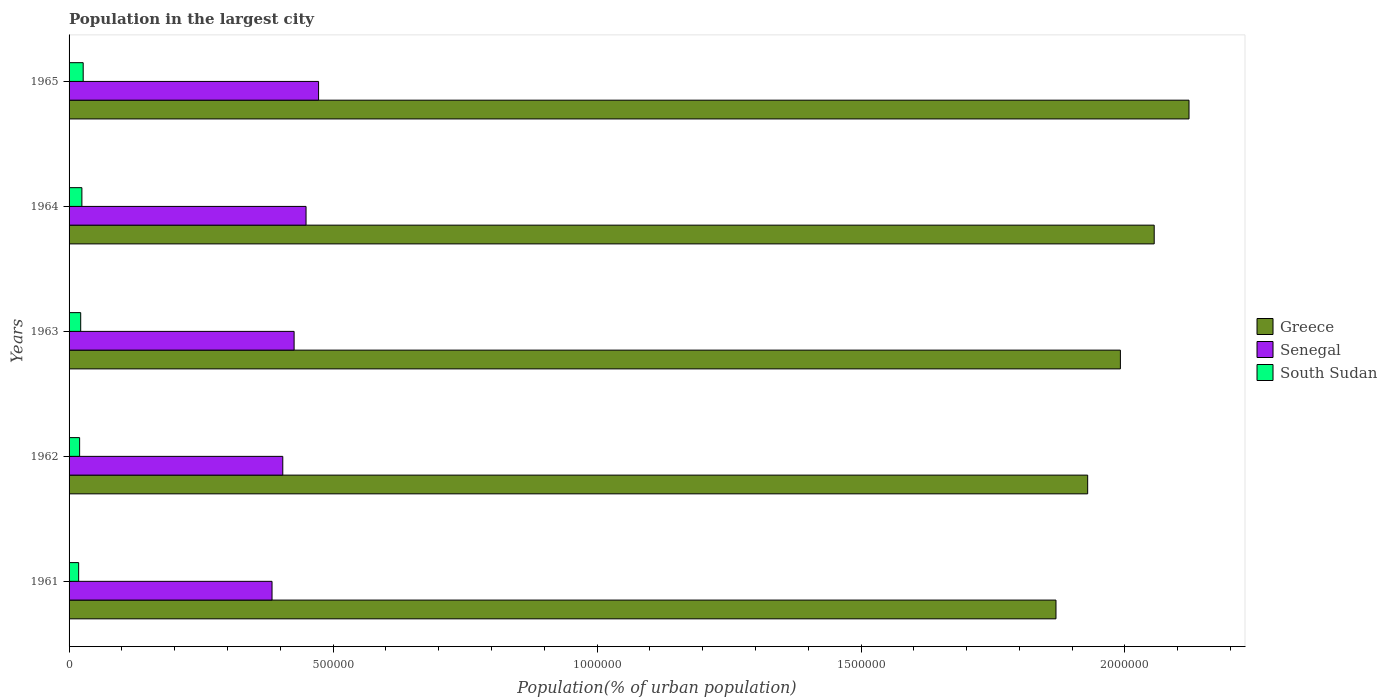Are the number of bars per tick equal to the number of legend labels?
Your answer should be very brief. Yes. Are the number of bars on each tick of the Y-axis equal?
Give a very brief answer. Yes. How many bars are there on the 2nd tick from the top?
Ensure brevity in your answer.  3. What is the label of the 2nd group of bars from the top?
Your answer should be very brief. 1964. What is the population in the largest city in Senegal in 1964?
Keep it short and to the point. 4.49e+05. Across all years, what is the maximum population in the largest city in Greece?
Make the answer very short. 2.12e+06. Across all years, what is the minimum population in the largest city in Senegal?
Your answer should be compact. 3.84e+05. In which year was the population in the largest city in South Sudan maximum?
Your answer should be compact. 1965. In which year was the population in the largest city in Senegal minimum?
Your answer should be very brief. 1961. What is the total population in the largest city in South Sudan in the graph?
Give a very brief answer. 1.11e+05. What is the difference between the population in the largest city in Senegal in 1961 and that in 1963?
Ensure brevity in your answer.  -4.18e+04. What is the difference between the population in the largest city in Greece in 1965 and the population in the largest city in South Sudan in 1961?
Ensure brevity in your answer.  2.10e+06. What is the average population in the largest city in Senegal per year?
Your answer should be compact. 4.27e+05. In the year 1963, what is the difference between the population in the largest city in Greece and population in the largest city in Senegal?
Ensure brevity in your answer.  1.57e+06. In how many years, is the population in the largest city in Greece greater than 1600000 %?
Give a very brief answer. 5. What is the ratio of the population in the largest city in Senegal in 1961 to that in 1965?
Your answer should be compact. 0.81. Is the population in the largest city in South Sudan in 1961 less than that in 1963?
Offer a very short reply. Yes. Is the difference between the population in the largest city in Greece in 1962 and 1965 greater than the difference between the population in the largest city in Senegal in 1962 and 1965?
Ensure brevity in your answer.  No. What is the difference between the highest and the second highest population in the largest city in Senegal?
Keep it short and to the point. 2.37e+04. What is the difference between the highest and the lowest population in the largest city in South Sudan?
Your answer should be compact. 8598. What does the 3rd bar from the top in 1962 represents?
Make the answer very short. Greece. Is it the case that in every year, the sum of the population in the largest city in South Sudan and population in the largest city in Senegal is greater than the population in the largest city in Greece?
Give a very brief answer. No. How many years are there in the graph?
Your answer should be compact. 5. Are the values on the major ticks of X-axis written in scientific E-notation?
Give a very brief answer. No. Does the graph contain any zero values?
Provide a short and direct response. No. Where does the legend appear in the graph?
Make the answer very short. Center right. What is the title of the graph?
Provide a succinct answer. Population in the largest city. Does "Faeroe Islands" appear as one of the legend labels in the graph?
Provide a succinct answer. No. What is the label or title of the X-axis?
Keep it short and to the point. Population(% of urban population). What is the label or title of the Y-axis?
Keep it short and to the point. Years. What is the Population(% of urban population) in Greece in 1961?
Make the answer very short. 1.87e+06. What is the Population(% of urban population) of Senegal in 1961?
Keep it short and to the point. 3.84e+05. What is the Population(% of urban population) in South Sudan in 1961?
Make the answer very short. 1.82e+04. What is the Population(% of urban population) in Greece in 1962?
Give a very brief answer. 1.93e+06. What is the Population(% of urban population) of Senegal in 1962?
Keep it short and to the point. 4.05e+05. What is the Population(% of urban population) in South Sudan in 1962?
Offer a terse response. 2.00e+04. What is the Population(% of urban population) in Greece in 1963?
Your answer should be very brief. 1.99e+06. What is the Population(% of urban population) of Senegal in 1963?
Give a very brief answer. 4.26e+05. What is the Population(% of urban population) of South Sudan in 1963?
Your response must be concise. 2.20e+04. What is the Population(% of urban population) in Greece in 1964?
Give a very brief answer. 2.06e+06. What is the Population(% of urban population) of Senegal in 1964?
Your answer should be compact. 4.49e+05. What is the Population(% of urban population) of South Sudan in 1964?
Give a very brief answer. 2.43e+04. What is the Population(% of urban population) of Greece in 1965?
Keep it short and to the point. 2.12e+06. What is the Population(% of urban population) of Senegal in 1965?
Your answer should be very brief. 4.73e+05. What is the Population(% of urban population) in South Sudan in 1965?
Provide a succinct answer. 2.68e+04. Across all years, what is the maximum Population(% of urban population) of Greece?
Provide a short and direct response. 2.12e+06. Across all years, what is the maximum Population(% of urban population) in Senegal?
Provide a short and direct response. 4.73e+05. Across all years, what is the maximum Population(% of urban population) in South Sudan?
Give a very brief answer. 2.68e+04. Across all years, what is the minimum Population(% of urban population) in Greece?
Your answer should be very brief. 1.87e+06. Across all years, what is the minimum Population(% of urban population) of Senegal?
Your answer should be very brief. 3.84e+05. Across all years, what is the minimum Population(% of urban population) in South Sudan?
Offer a terse response. 1.82e+04. What is the total Population(% of urban population) in Greece in the graph?
Offer a terse response. 9.97e+06. What is the total Population(% of urban population) of Senegal in the graph?
Provide a short and direct response. 2.14e+06. What is the total Population(% of urban population) in South Sudan in the graph?
Keep it short and to the point. 1.11e+05. What is the difference between the Population(% of urban population) of Greece in 1961 and that in 1962?
Your answer should be very brief. -6.00e+04. What is the difference between the Population(% of urban population) of Senegal in 1961 and that in 1962?
Offer a terse response. -2.04e+04. What is the difference between the Population(% of urban population) in South Sudan in 1961 and that in 1962?
Your answer should be very brief. -1848. What is the difference between the Population(% of urban population) of Greece in 1961 and that in 1963?
Offer a terse response. -1.22e+05. What is the difference between the Population(% of urban population) in Senegal in 1961 and that in 1963?
Give a very brief answer. -4.18e+04. What is the difference between the Population(% of urban population) in South Sudan in 1961 and that in 1963?
Give a very brief answer. -3884. What is the difference between the Population(% of urban population) of Greece in 1961 and that in 1964?
Ensure brevity in your answer.  -1.86e+05. What is the difference between the Population(% of urban population) in Senegal in 1961 and that in 1964?
Ensure brevity in your answer.  -6.44e+04. What is the difference between the Population(% of urban population) in South Sudan in 1961 and that in 1964?
Provide a succinct answer. -6130. What is the difference between the Population(% of urban population) in Greece in 1961 and that in 1965?
Your response must be concise. -2.52e+05. What is the difference between the Population(% of urban population) of Senegal in 1961 and that in 1965?
Your answer should be compact. -8.82e+04. What is the difference between the Population(% of urban population) in South Sudan in 1961 and that in 1965?
Make the answer very short. -8598. What is the difference between the Population(% of urban population) in Greece in 1962 and that in 1963?
Keep it short and to the point. -6.20e+04. What is the difference between the Population(% of urban population) of Senegal in 1962 and that in 1963?
Keep it short and to the point. -2.14e+04. What is the difference between the Population(% of urban population) in South Sudan in 1962 and that in 1963?
Keep it short and to the point. -2036. What is the difference between the Population(% of urban population) in Greece in 1962 and that in 1964?
Provide a succinct answer. -1.26e+05. What is the difference between the Population(% of urban population) of Senegal in 1962 and that in 1964?
Provide a short and direct response. -4.41e+04. What is the difference between the Population(% of urban population) in South Sudan in 1962 and that in 1964?
Provide a succinct answer. -4282. What is the difference between the Population(% of urban population) in Greece in 1962 and that in 1965?
Give a very brief answer. -1.92e+05. What is the difference between the Population(% of urban population) of Senegal in 1962 and that in 1965?
Your answer should be compact. -6.78e+04. What is the difference between the Population(% of urban population) in South Sudan in 1962 and that in 1965?
Provide a succinct answer. -6750. What is the difference between the Population(% of urban population) in Greece in 1963 and that in 1964?
Make the answer very short. -6.40e+04. What is the difference between the Population(% of urban population) of Senegal in 1963 and that in 1964?
Provide a short and direct response. -2.26e+04. What is the difference between the Population(% of urban population) of South Sudan in 1963 and that in 1964?
Offer a very short reply. -2246. What is the difference between the Population(% of urban population) of Greece in 1963 and that in 1965?
Offer a very short reply. -1.30e+05. What is the difference between the Population(% of urban population) in Senegal in 1963 and that in 1965?
Ensure brevity in your answer.  -4.64e+04. What is the difference between the Population(% of urban population) in South Sudan in 1963 and that in 1965?
Make the answer very short. -4714. What is the difference between the Population(% of urban population) of Greece in 1964 and that in 1965?
Give a very brief answer. -6.59e+04. What is the difference between the Population(% of urban population) in Senegal in 1964 and that in 1965?
Your answer should be very brief. -2.37e+04. What is the difference between the Population(% of urban population) of South Sudan in 1964 and that in 1965?
Offer a very short reply. -2468. What is the difference between the Population(% of urban population) in Greece in 1961 and the Population(% of urban population) in Senegal in 1962?
Your response must be concise. 1.46e+06. What is the difference between the Population(% of urban population) in Greece in 1961 and the Population(% of urban population) in South Sudan in 1962?
Ensure brevity in your answer.  1.85e+06. What is the difference between the Population(% of urban population) of Senegal in 1961 and the Population(% of urban population) of South Sudan in 1962?
Offer a very short reply. 3.64e+05. What is the difference between the Population(% of urban population) in Greece in 1961 and the Population(% of urban population) in Senegal in 1963?
Give a very brief answer. 1.44e+06. What is the difference between the Population(% of urban population) of Greece in 1961 and the Population(% of urban population) of South Sudan in 1963?
Offer a very short reply. 1.85e+06. What is the difference between the Population(% of urban population) in Senegal in 1961 and the Population(% of urban population) in South Sudan in 1963?
Your answer should be very brief. 3.62e+05. What is the difference between the Population(% of urban population) in Greece in 1961 and the Population(% of urban population) in Senegal in 1964?
Keep it short and to the point. 1.42e+06. What is the difference between the Population(% of urban population) in Greece in 1961 and the Population(% of urban population) in South Sudan in 1964?
Ensure brevity in your answer.  1.85e+06. What is the difference between the Population(% of urban population) of Senegal in 1961 and the Population(% of urban population) of South Sudan in 1964?
Make the answer very short. 3.60e+05. What is the difference between the Population(% of urban population) of Greece in 1961 and the Population(% of urban population) of Senegal in 1965?
Ensure brevity in your answer.  1.40e+06. What is the difference between the Population(% of urban population) in Greece in 1961 and the Population(% of urban population) in South Sudan in 1965?
Offer a very short reply. 1.84e+06. What is the difference between the Population(% of urban population) in Senegal in 1961 and the Population(% of urban population) in South Sudan in 1965?
Your answer should be very brief. 3.58e+05. What is the difference between the Population(% of urban population) in Greece in 1962 and the Population(% of urban population) in Senegal in 1963?
Keep it short and to the point. 1.50e+06. What is the difference between the Population(% of urban population) of Greece in 1962 and the Population(% of urban population) of South Sudan in 1963?
Your response must be concise. 1.91e+06. What is the difference between the Population(% of urban population) of Senegal in 1962 and the Population(% of urban population) of South Sudan in 1963?
Provide a short and direct response. 3.83e+05. What is the difference between the Population(% of urban population) in Greece in 1962 and the Population(% of urban population) in Senegal in 1964?
Ensure brevity in your answer.  1.48e+06. What is the difference between the Population(% of urban population) in Greece in 1962 and the Population(% of urban population) in South Sudan in 1964?
Provide a short and direct response. 1.91e+06. What is the difference between the Population(% of urban population) of Senegal in 1962 and the Population(% of urban population) of South Sudan in 1964?
Give a very brief answer. 3.81e+05. What is the difference between the Population(% of urban population) in Greece in 1962 and the Population(% of urban population) in Senegal in 1965?
Your answer should be compact. 1.46e+06. What is the difference between the Population(% of urban population) in Greece in 1962 and the Population(% of urban population) in South Sudan in 1965?
Ensure brevity in your answer.  1.90e+06. What is the difference between the Population(% of urban population) of Senegal in 1962 and the Population(% of urban population) of South Sudan in 1965?
Offer a very short reply. 3.78e+05. What is the difference between the Population(% of urban population) of Greece in 1963 and the Population(% of urban population) of Senegal in 1964?
Offer a terse response. 1.54e+06. What is the difference between the Population(% of urban population) in Greece in 1963 and the Population(% of urban population) in South Sudan in 1964?
Ensure brevity in your answer.  1.97e+06. What is the difference between the Population(% of urban population) in Senegal in 1963 and the Population(% of urban population) in South Sudan in 1964?
Your response must be concise. 4.02e+05. What is the difference between the Population(% of urban population) in Greece in 1963 and the Population(% of urban population) in Senegal in 1965?
Your answer should be compact. 1.52e+06. What is the difference between the Population(% of urban population) in Greece in 1963 and the Population(% of urban population) in South Sudan in 1965?
Offer a very short reply. 1.96e+06. What is the difference between the Population(% of urban population) in Senegal in 1963 and the Population(% of urban population) in South Sudan in 1965?
Provide a succinct answer. 3.99e+05. What is the difference between the Population(% of urban population) in Greece in 1964 and the Population(% of urban population) in Senegal in 1965?
Offer a terse response. 1.58e+06. What is the difference between the Population(% of urban population) of Greece in 1964 and the Population(% of urban population) of South Sudan in 1965?
Provide a short and direct response. 2.03e+06. What is the difference between the Population(% of urban population) of Senegal in 1964 and the Population(% of urban population) of South Sudan in 1965?
Make the answer very short. 4.22e+05. What is the average Population(% of urban population) in Greece per year?
Your answer should be very brief. 1.99e+06. What is the average Population(% of urban population) in Senegal per year?
Your answer should be compact. 4.27e+05. What is the average Population(% of urban population) of South Sudan per year?
Provide a short and direct response. 2.22e+04. In the year 1961, what is the difference between the Population(% of urban population) of Greece and Population(% of urban population) of Senegal?
Your response must be concise. 1.48e+06. In the year 1961, what is the difference between the Population(% of urban population) in Greece and Population(% of urban population) in South Sudan?
Give a very brief answer. 1.85e+06. In the year 1961, what is the difference between the Population(% of urban population) of Senegal and Population(% of urban population) of South Sudan?
Your answer should be compact. 3.66e+05. In the year 1962, what is the difference between the Population(% of urban population) in Greece and Population(% of urban population) in Senegal?
Make the answer very short. 1.52e+06. In the year 1962, what is the difference between the Population(% of urban population) of Greece and Population(% of urban population) of South Sudan?
Your answer should be compact. 1.91e+06. In the year 1962, what is the difference between the Population(% of urban population) of Senegal and Population(% of urban population) of South Sudan?
Keep it short and to the point. 3.85e+05. In the year 1963, what is the difference between the Population(% of urban population) in Greece and Population(% of urban population) in Senegal?
Keep it short and to the point. 1.57e+06. In the year 1963, what is the difference between the Population(% of urban population) of Greece and Population(% of urban population) of South Sudan?
Offer a very short reply. 1.97e+06. In the year 1963, what is the difference between the Population(% of urban population) in Senegal and Population(% of urban population) in South Sudan?
Ensure brevity in your answer.  4.04e+05. In the year 1964, what is the difference between the Population(% of urban population) in Greece and Population(% of urban population) in Senegal?
Make the answer very short. 1.61e+06. In the year 1964, what is the difference between the Population(% of urban population) in Greece and Population(% of urban population) in South Sudan?
Ensure brevity in your answer.  2.03e+06. In the year 1964, what is the difference between the Population(% of urban population) in Senegal and Population(% of urban population) in South Sudan?
Make the answer very short. 4.25e+05. In the year 1965, what is the difference between the Population(% of urban population) of Greece and Population(% of urban population) of Senegal?
Make the answer very short. 1.65e+06. In the year 1965, what is the difference between the Population(% of urban population) in Greece and Population(% of urban population) in South Sudan?
Your answer should be compact. 2.09e+06. In the year 1965, what is the difference between the Population(% of urban population) of Senegal and Population(% of urban population) of South Sudan?
Give a very brief answer. 4.46e+05. What is the ratio of the Population(% of urban population) of Greece in 1961 to that in 1962?
Offer a very short reply. 0.97. What is the ratio of the Population(% of urban population) in Senegal in 1961 to that in 1962?
Provide a succinct answer. 0.95. What is the ratio of the Population(% of urban population) in South Sudan in 1961 to that in 1962?
Make the answer very short. 0.91. What is the ratio of the Population(% of urban population) of Greece in 1961 to that in 1963?
Your response must be concise. 0.94. What is the ratio of the Population(% of urban population) in Senegal in 1961 to that in 1963?
Offer a very short reply. 0.9. What is the ratio of the Population(% of urban population) of South Sudan in 1961 to that in 1963?
Give a very brief answer. 0.82. What is the ratio of the Population(% of urban population) of Greece in 1961 to that in 1964?
Your answer should be very brief. 0.91. What is the ratio of the Population(% of urban population) of Senegal in 1961 to that in 1964?
Give a very brief answer. 0.86. What is the ratio of the Population(% of urban population) in South Sudan in 1961 to that in 1964?
Make the answer very short. 0.75. What is the ratio of the Population(% of urban population) of Greece in 1961 to that in 1965?
Give a very brief answer. 0.88. What is the ratio of the Population(% of urban population) in Senegal in 1961 to that in 1965?
Give a very brief answer. 0.81. What is the ratio of the Population(% of urban population) of South Sudan in 1961 to that in 1965?
Provide a succinct answer. 0.68. What is the ratio of the Population(% of urban population) in Greece in 1962 to that in 1963?
Ensure brevity in your answer.  0.97. What is the ratio of the Population(% of urban population) of Senegal in 1962 to that in 1963?
Provide a short and direct response. 0.95. What is the ratio of the Population(% of urban population) in South Sudan in 1962 to that in 1963?
Offer a very short reply. 0.91. What is the ratio of the Population(% of urban population) in Greece in 1962 to that in 1964?
Offer a terse response. 0.94. What is the ratio of the Population(% of urban population) in Senegal in 1962 to that in 1964?
Provide a succinct answer. 0.9. What is the ratio of the Population(% of urban population) in South Sudan in 1962 to that in 1964?
Keep it short and to the point. 0.82. What is the ratio of the Population(% of urban population) of Greece in 1962 to that in 1965?
Offer a terse response. 0.91. What is the ratio of the Population(% of urban population) of Senegal in 1962 to that in 1965?
Offer a terse response. 0.86. What is the ratio of the Population(% of urban population) of South Sudan in 1962 to that in 1965?
Your answer should be very brief. 0.75. What is the ratio of the Population(% of urban population) in Greece in 1963 to that in 1964?
Your answer should be very brief. 0.97. What is the ratio of the Population(% of urban population) of Senegal in 1963 to that in 1964?
Your response must be concise. 0.95. What is the ratio of the Population(% of urban population) of South Sudan in 1963 to that in 1964?
Give a very brief answer. 0.91. What is the ratio of the Population(% of urban population) of Greece in 1963 to that in 1965?
Offer a terse response. 0.94. What is the ratio of the Population(% of urban population) in Senegal in 1963 to that in 1965?
Offer a very short reply. 0.9. What is the ratio of the Population(% of urban population) in South Sudan in 1963 to that in 1965?
Offer a very short reply. 0.82. What is the ratio of the Population(% of urban population) in Greece in 1964 to that in 1965?
Keep it short and to the point. 0.97. What is the ratio of the Population(% of urban population) of Senegal in 1964 to that in 1965?
Provide a succinct answer. 0.95. What is the ratio of the Population(% of urban population) in South Sudan in 1964 to that in 1965?
Your answer should be very brief. 0.91. What is the difference between the highest and the second highest Population(% of urban population) of Greece?
Offer a terse response. 6.59e+04. What is the difference between the highest and the second highest Population(% of urban population) in Senegal?
Provide a short and direct response. 2.37e+04. What is the difference between the highest and the second highest Population(% of urban population) in South Sudan?
Provide a short and direct response. 2468. What is the difference between the highest and the lowest Population(% of urban population) in Greece?
Keep it short and to the point. 2.52e+05. What is the difference between the highest and the lowest Population(% of urban population) of Senegal?
Offer a very short reply. 8.82e+04. What is the difference between the highest and the lowest Population(% of urban population) of South Sudan?
Give a very brief answer. 8598. 